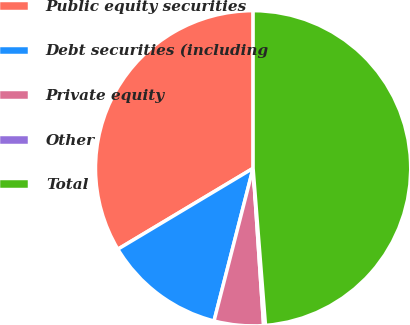Convert chart to OTSL. <chart><loc_0><loc_0><loc_500><loc_500><pie_chart><fcel>Public equity securities<fcel>Debt securities (including<fcel>Private equity<fcel>Other<fcel>Total<nl><fcel>33.58%<fcel>12.43%<fcel>5.05%<fcel>0.19%<fcel>48.74%<nl></chart> 